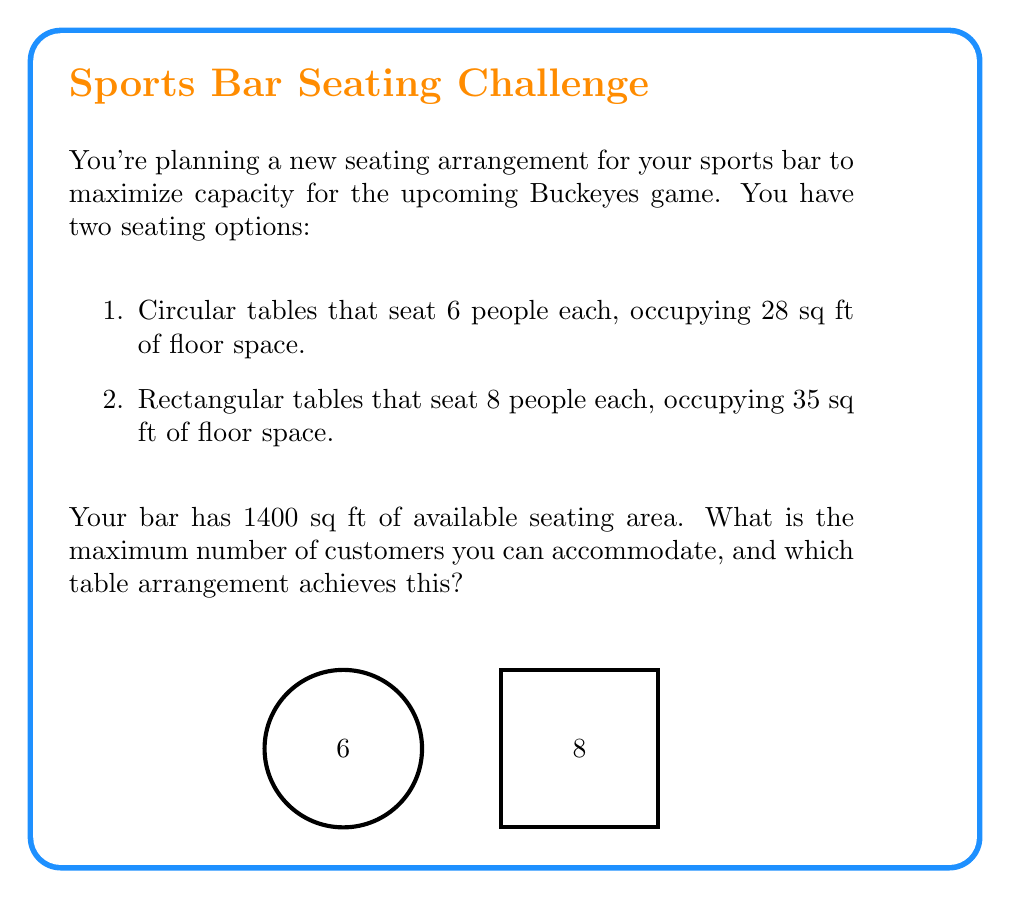Solve this math problem. Let's approach this step-by-step:

1) Let $x$ be the number of circular tables and $y$ be the number of rectangular tables.

2) The constraint for floor space can be expressed as:
   $28x + 35y \leq 1400$

3) We want to maximize the number of customers, which can be expressed as:
   $\text{Maximize } 6x + 8y$

4) This is a linear programming problem. We can solve it by considering the extreme points:

   a) If we use only circular tables:
      $28x = 1400$
      $x = 50$
      Customers = $6 \times 50 = 300$

   b) If we use only rectangular tables:
      $35y = 1400$
      $y = 40$
      Customers = $8 \times 40 = 320$

   c) If we use a mix, the optimal point will be at the intersection of the constraint line and one of the axes.

5) The rectangular tables accommodate more people per square foot:
   Circular: $\frac{6}{28} = 0.214$ people/sq ft
   Rectangular: $\frac{8}{35} = 0.229$ people/sq ft

6) Therefore, the optimal solution is to use only rectangular tables.

7) The maximum number of customers: $320$
Answer: 320 customers, using only rectangular tables. 